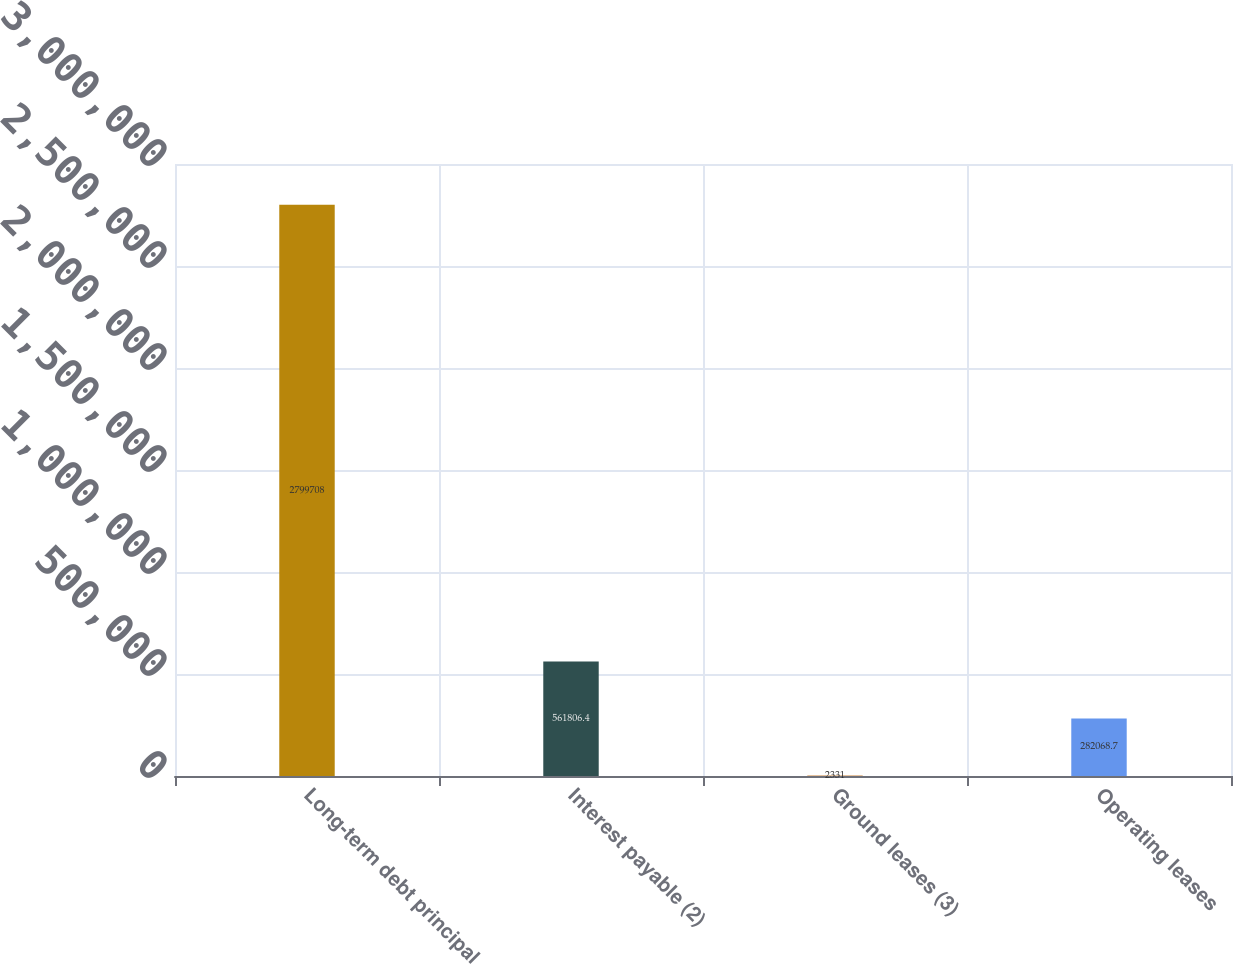Convert chart. <chart><loc_0><loc_0><loc_500><loc_500><bar_chart><fcel>Long-term debt principal<fcel>Interest payable (2)<fcel>Ground leases (3)<fcel>Operating leases<nl><fcel>2.79971e+06<fcel>561806<fcel>2331<fcel>282069<nl></chart> 